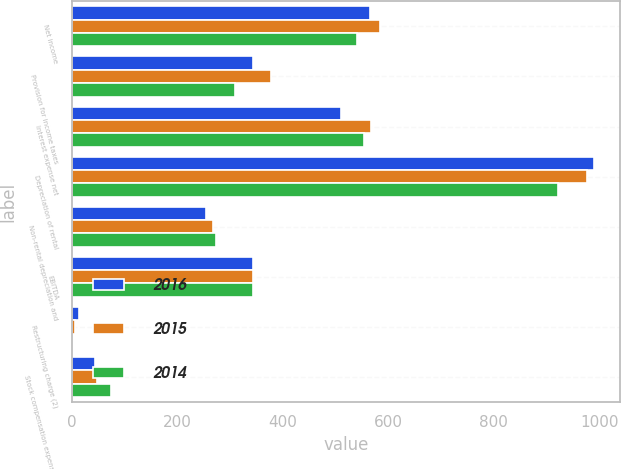Convert chart to OTSL. <chart><loc_0><loc_0><loc_500><loc_500><stacked_bar_chart><ecel><fcel>Net income<fcel>Provision for income taxes<fcel>Interest expense net<fcel>Depreciation of rental<fcel>Non-rental depreciation and<fcel>EBITDA<fcel>Restructuring charge (2)<fcel>Stock compensation expense net<nl><fcel>2016<fcel>566<fcel>343<fcel>511<fcel>990<fcel>255<fcel>343<fcel>14<fcel>45<nl><fcel>2015<fcel>585<fcel>378<fcel>567<fcel>976<fcel>268<fcel>343<fcel>6<fcel>49<nl><fcel>2014<fcel>540<fcel>310<fcel>555<fcel>921<fcel>273<fcel>343<fcel>1<fcel>74<nl></chart> 